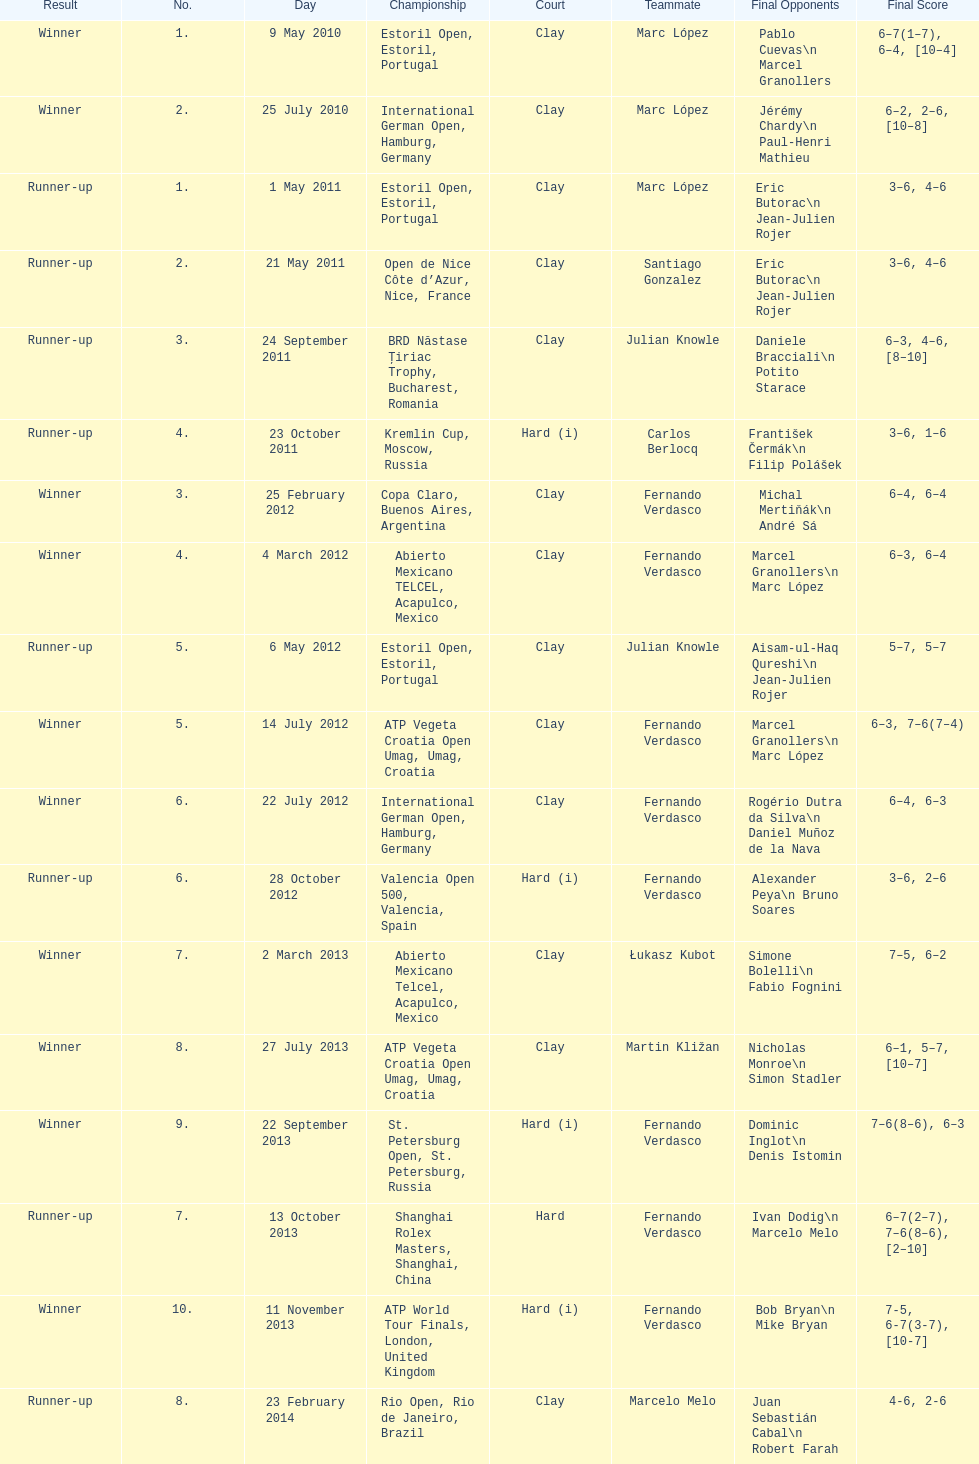What is the number of winning outcomes? 10. 